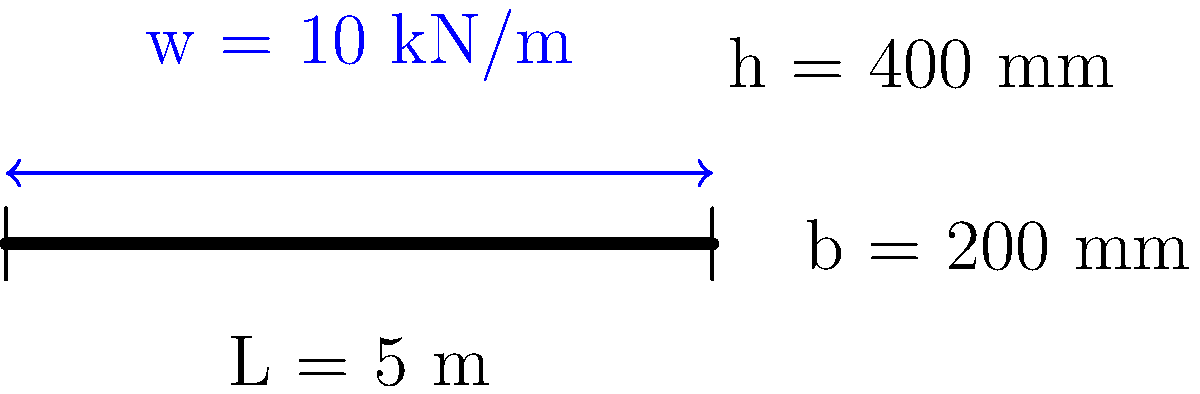As a wise neighbor with parenting knowledge, you're helping a child with their engineering homework. The question is about a simply supported beam made of concrete with the following properties:

- Length (L) = 5 m
- Width (b) = 200 mm
- Height (h) = 400 mm
- Concrete compressive strength (f'c) = 30 MPa
- Distributed load (w) = 10 kN/m

Calculate the maximum bending moment in the beam. Round your answer to the nearest whole number. Let's break this down step-by-step:

1) For a simply supported beam with a uniformly distributed load, the maximum bending moment occurs at the center of the beam.

2) The formula for the maximum bending moment (M_max) is:

   $$M_{max} = \frac{wL^2}{8}$$

   Where:
   w = distributed load
   L = length of the beam

3) We have:
   w = 10 kN/m
   L = 5 m

4) Let's substitute these values into our equation:

   $$M_{max} = \frac{10 \times 5^2}{8} = \frac{10 \times 25}{8} = \frac{250}{8} = 31.25 \text{ kN⋅m}$$

5) Rounding to the nearest whole number:

   M_max ≈ 31 kN⋅m

This is a simplified explanation suitable for a child's homework. In real-world engineering, we would also need to check if this moment exceeds the beam's capacity, which would involve more complex calculations considering the beam's material properties and cross-sectional dimensions.
Answer: 31 kN⋅m 